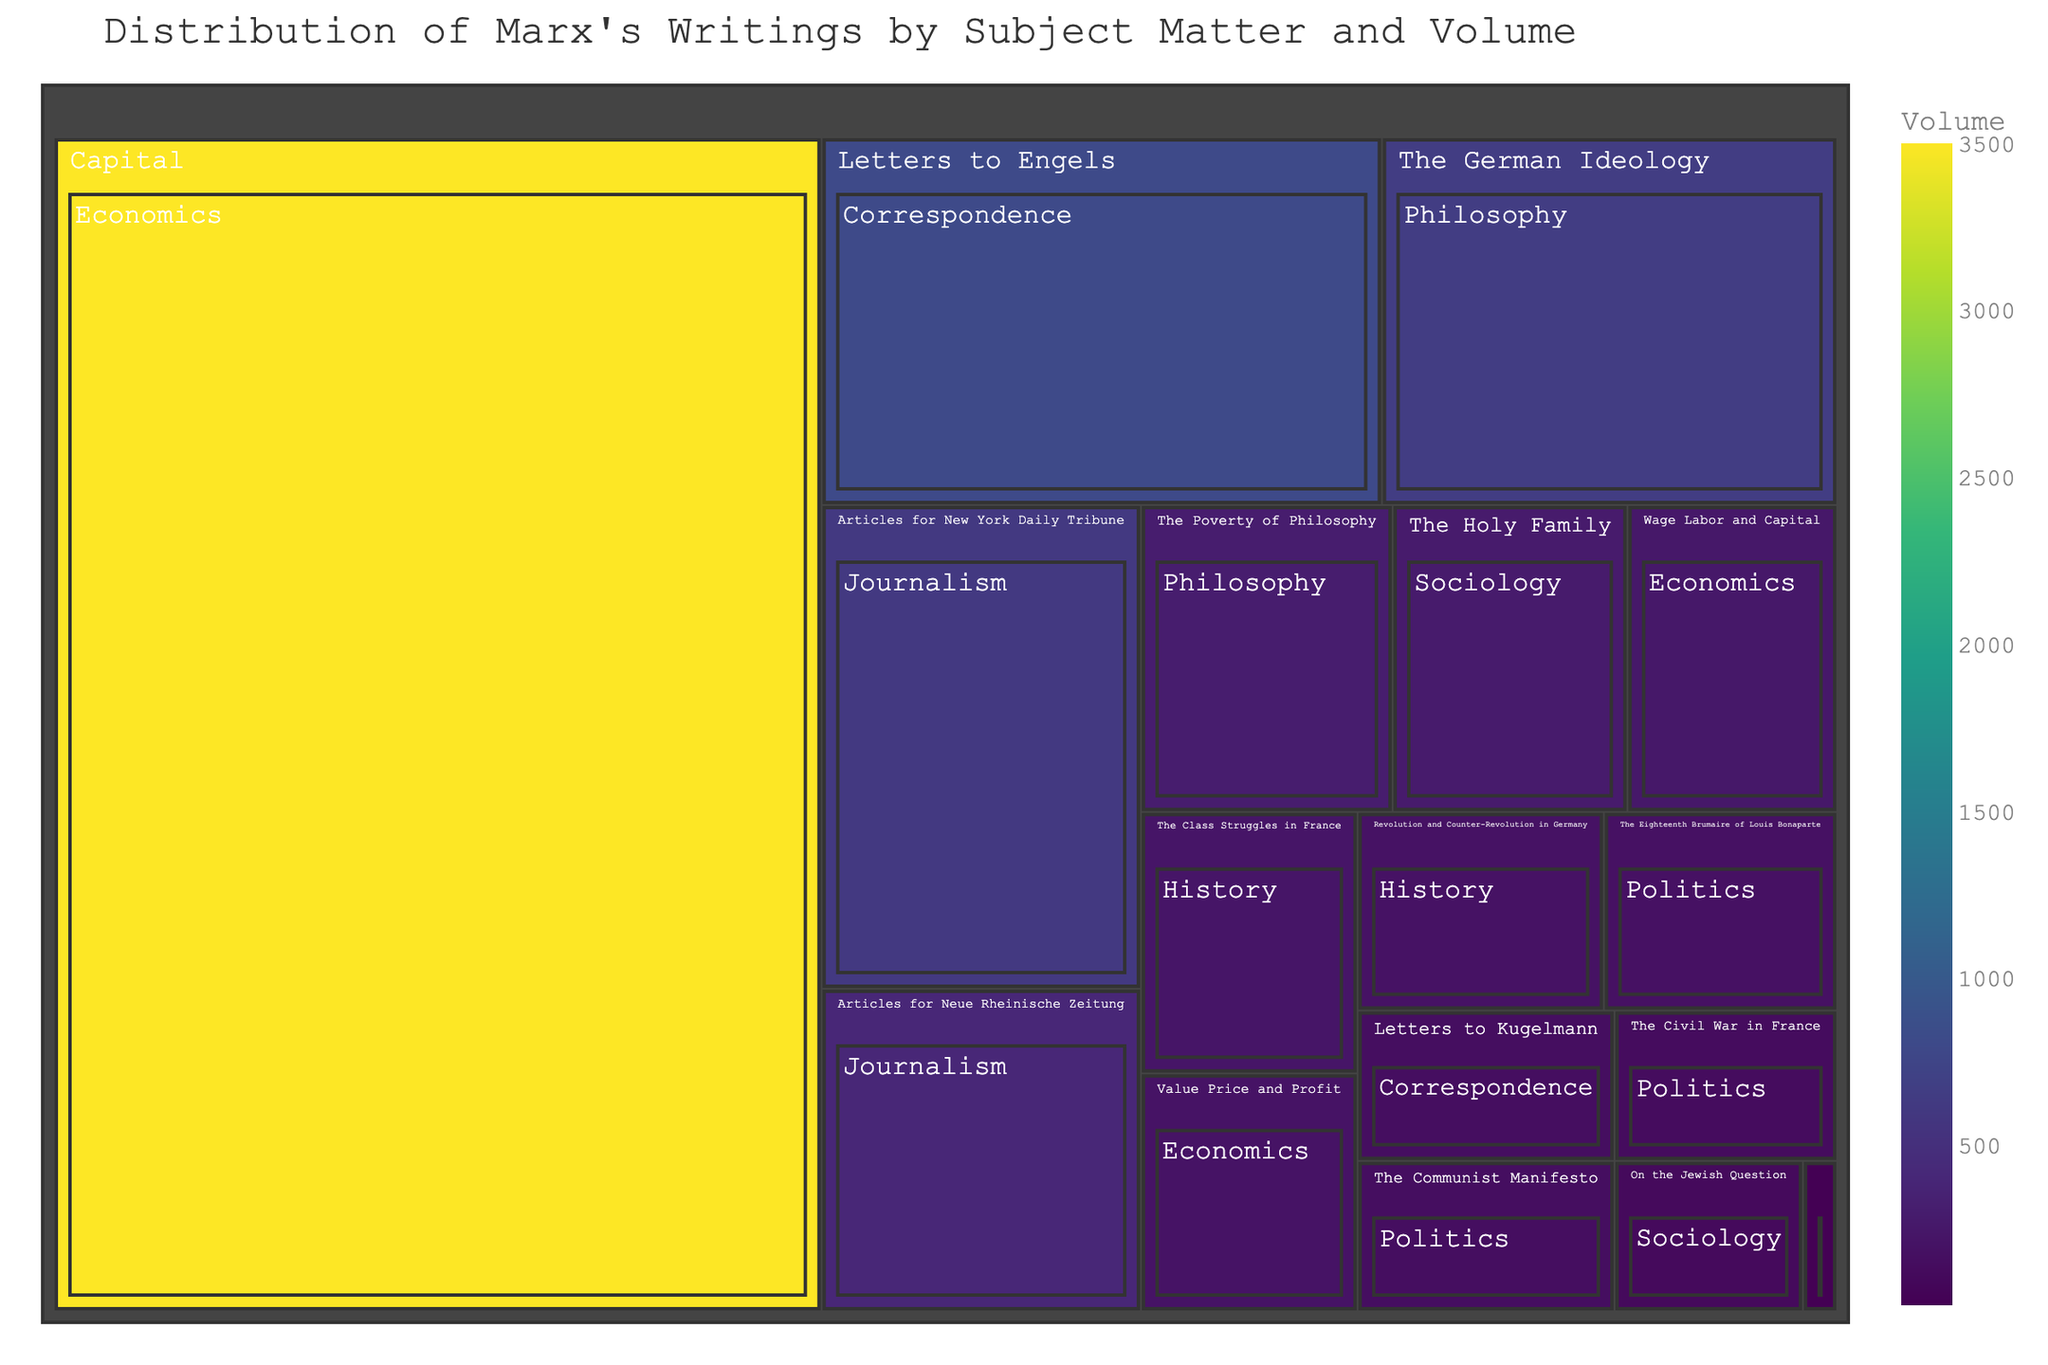What's the largest category by volume? The Treemap allows us to visually compare the sizes of different categories. The category with the largest segment is "Capital" under "Economics".
Answer: Economics How many distinct subjects are covered in Marx's writings? By counting the number of distinct segments in the Treemap, we can determine the number of distinct subjects. There are 17 distinct subjects represented in the Treemap.
Answer: 17 Which work in the "Politics" category has the highest volume? In the Treemap, the size of each rectangle corresponds to the volume. The largest rectangle in the "Politics" category is "The Communist Manifesto".
Answer: The Communist Manifesto What's the total volume for the "Philosophy" category? Add up the volumes associated with the Philosophy category: 650 (The German Ideology) + 20 (Theses on Feuerbach) + 300 (The Poverty of Philosophy) = 970.
Answer: 970 How does the volume of "Letters to Engels" compare to "Articles for New York Daily Tribune"? Compare the sizes of the two specific segments. "Letters to Engels" have a volume of 800, whereas "Articles for New York Daily Tribune" have a volume of 600. 800 is greater than 600.
Answer: Letters to Engels is greater What percentage of the total volume does "Capital" constitute? First, find the total volume sum: 3500+250+200+650+20+300+150+180+130+220+190+110+280+800+150+400+600=8130. "Capital" volume is 3500. Calculate percentage as (3500/8130)*100 ≈ 43.05%.
Answer: 43.05% Which category contains the smallest work by volume? Identify the smallest segment in the Treemap. The smallest work is "Theses on Feuerbach" with a volume of 20, under the "Philosophy" category.
Answer: Philosophy Is there a notable difference between the volumes of "Journalism" and "Correspondence"? Sum the volumes under Journalism (400+600=1000) and Correspondence (800+150=950). Compare: 1000 (Journalism) vs 950 (Correspondence).
Answer: Journalism has slightly more How many works fall under the "Economics" category? Count the number of segments within the "Economics" category: "Capital", "Wage Labor and Capital", "Value Price and Profit". There are 3 works under Economics.
Answer: 3 Does "On the Jewish Question" have a higher or lower volume than "The Holy Family"? Compare the volumes: "On the Jewish Question" is 110, and "The Holy Family" is 280. 110 is less than 280.
Answer: Lower 